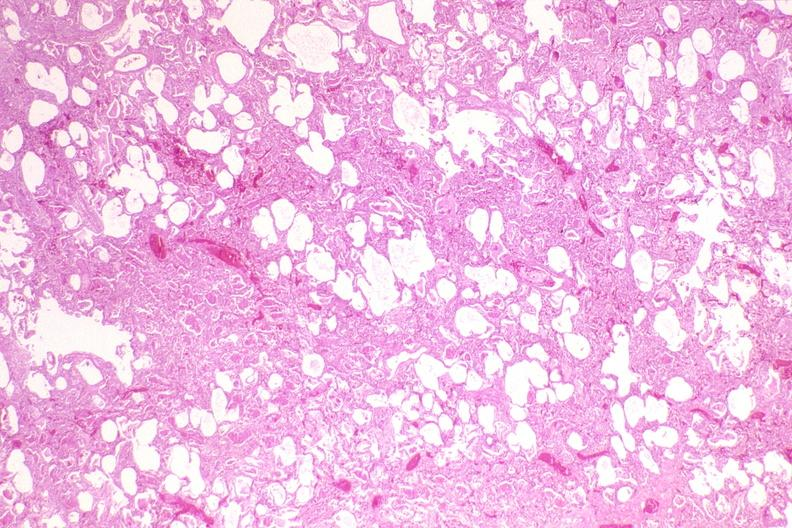s chronic lymphocytic leukemia present?
Answer the question using a single word or phrase. No 